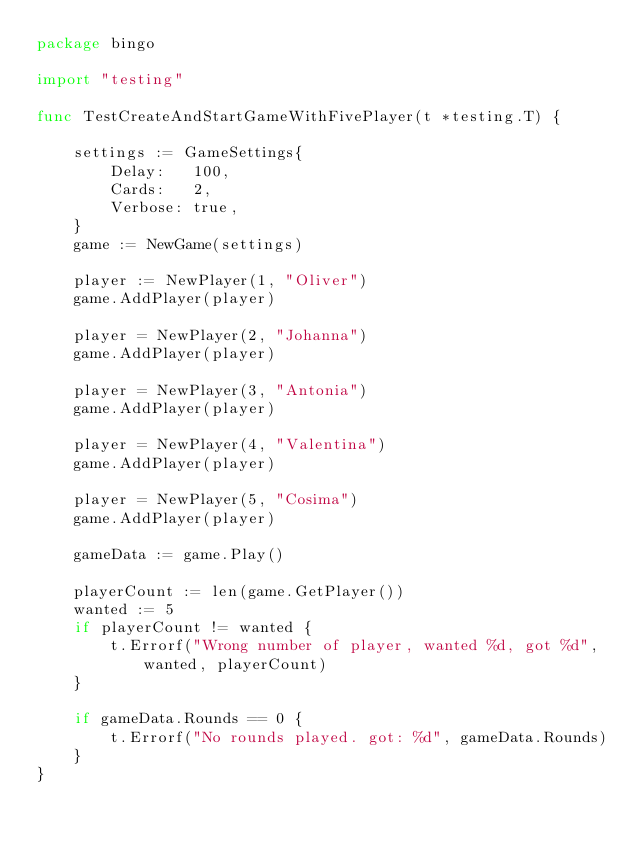Convert code to text. <code><loc_0><loc_0><loc_500><loc_500><_Go_>package bingo

import "testing"

func TestCreateAndStartGameWithFivePlayer(t *testing.T) {

	settings := GameSettings{
		Delay:   100,
		Cards:   2,
		Verbose: true,
	}
	game := NewGame(settings)

	player := NewPlayer(1, "Oliver")
	game.AddPlayer(player)

	player = NewPlayer(2, "Johanna")
	game.AddPlayer(player)

	player = NewPlayer(3, "Antonia")
	game.AddPlayer(player)

	player = NewPlayer(4, "Valentina")
	game.AddPlayer(player)

	player = NewPlayer(5, "Cosima")
	game.AddPlayer(player)

	gameData := game.Play()

	playerCount := len(game.GetPlayer())
	wanted := 5
	if playerCount != wanted {
		t.Errorf("Wrong number of player, wanted %d, got %d", wanted, playerCount)
	}

	if gameData.Rounds == 0 {
		t.Errorf("No rounds played. got: %d", gameData.Rounds)
	}
}
</code> 